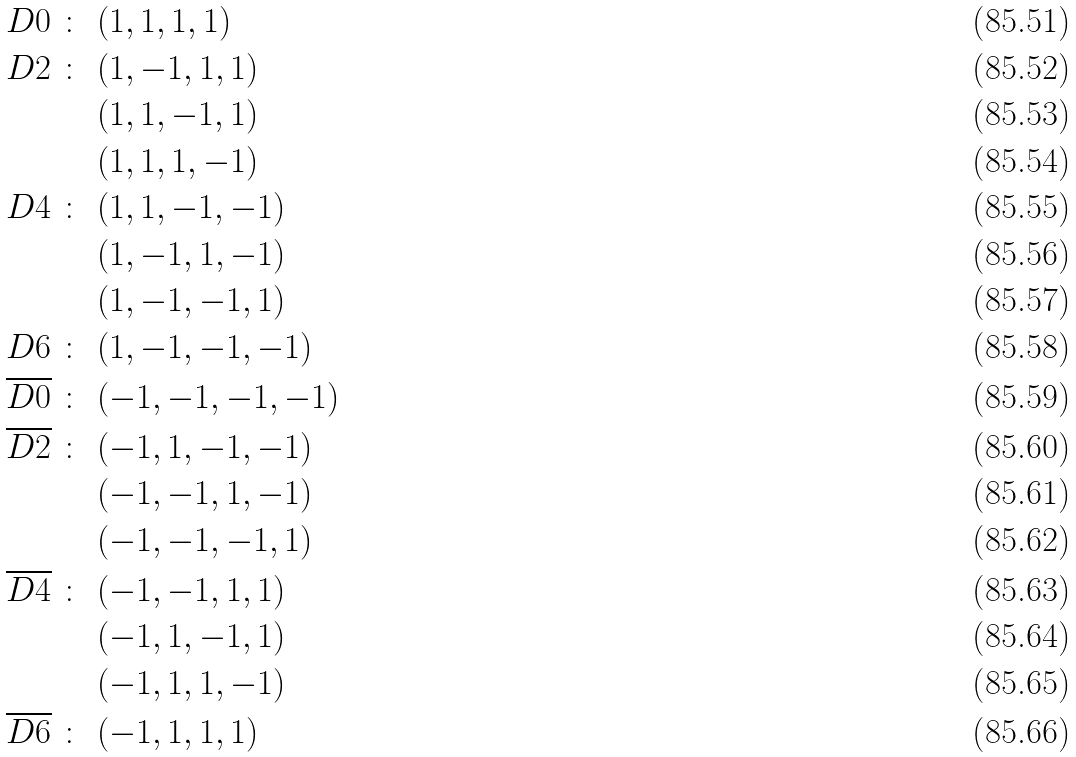<formula> <loc_0><loc_0><loc_500><loc_500>D 0 \ \colon \ & ( 1 , 1 , 1 , 1 ) \\ D 2 \ \colon \ & ( 1 , - 1 , 1 , 1 ) \\ & ( 1 , 1 , - 1 , 1 ) \\ & ( 1 , 1 , 1 , - 1 ) \\ D 4 \ \colon \ & ( 1 , 1 , - 1 , - 1 ) \\ & ( 1 , - 1 , 1 , - 1 ) \\ & ( 1 , - 1 , - 1 , 1 ) \\ D 6 \ \colon \ & ( 1 , - 1 , - 1 , - 1 ) \\ \overline { D 0 } \ \colon \ & ( - 1 , - 1 , - 1 , - 1 ) \\ \overline { D 2 } \ \colon \ & ( - 1 , 1 , - 1 , - 1 ) \\ & ( - 1 , - 1 , 1 , - 1 ) \\ & ( - 1 , - 1 , - 1 , 1 ) \\ \overline { D 4 } \ \colon \ & ( - 1 , - 1 , 1 , 1 ) \\ & ( - 1 , 1 , - 1 , 1 ) \\ & ( - 1 , 1 , 1 , - 1 ) \\ \overline { D 6 } \ \colon \ & ( - 1 , 1 , 1 , 1 )</formula> 